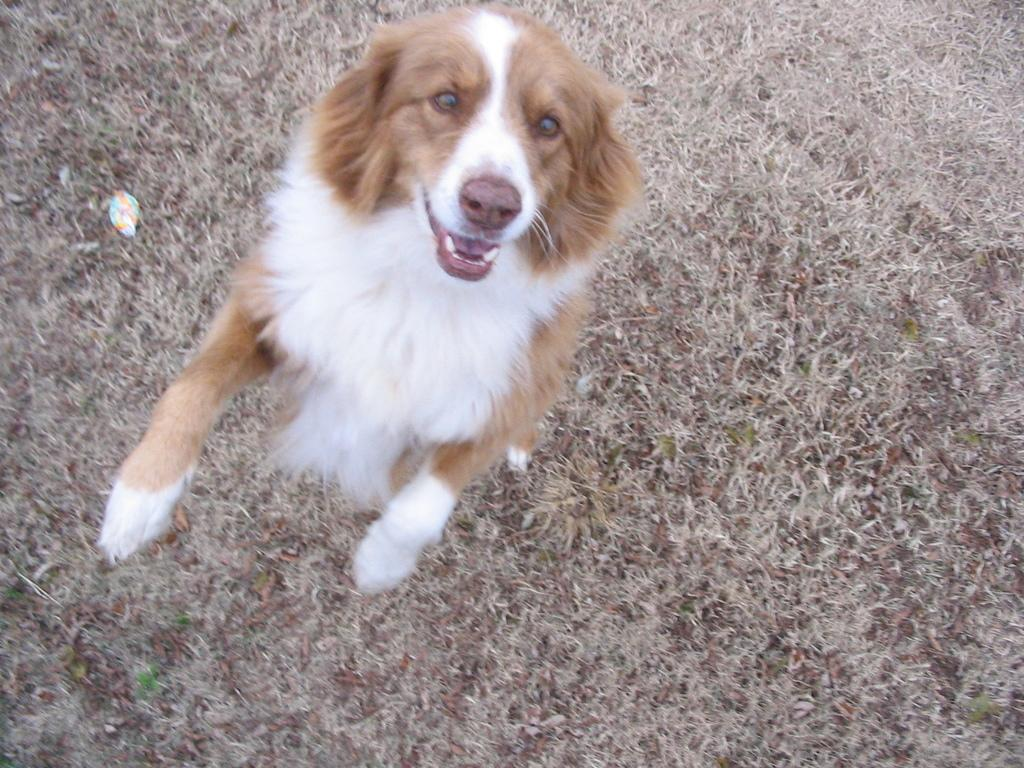What type of animal is present in the image? There is a dog in the image. Can you describe the position of the dog in the image? The dog is on the ground in the image. What type of vegetation can be seen in the image? There is dry grass visible in the image. What type of transport is visible in the image? There is no transport present in the image. Can you see any ships in the image? There is no ship present in the image. What type of bread is the dog holding in the image? There is no bread present in the image, and the dog is not holding anything. 